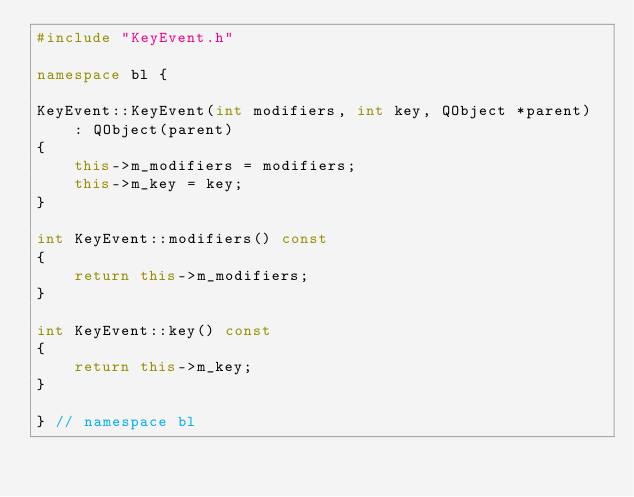<code> <loc_0><loc_0><loc_500><loc_500><_C++_>#include "KeyEvent.h"

namespace bl {

KeyEvent::KeyEvent(int modifiers, int key, QObject *parent)
    : QObject(parent)
{
    this->m_modifiers = modifiers;
    this->m_key = key;
}

int KeyEvent::modifiers() const
{
    return this->m_modifiers;
}

int KeyEvent::key() const
{
    return this->m_key;
}

} // namespace bl
</code> 